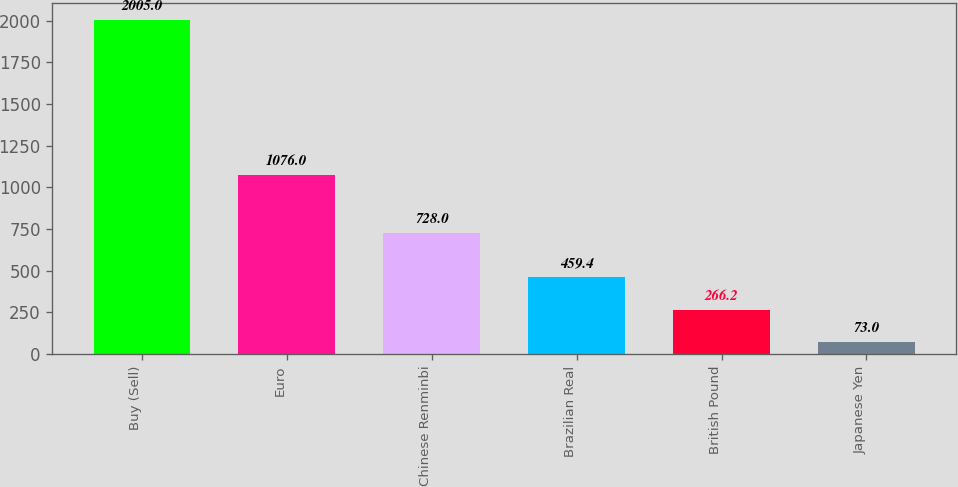Convert chart. <chart><loc_0><loc_0><loc_500><loc_500><bar_chart><fcel>Buy (Sell)<fcel>Euro<fcel>Chinese Renminbi<fcel>Brazilian Real<fcel>British Pound<fcel>Japanese Yen<nl><fcel>2005<fcel>1076<fcel>728<fcel>459.4<fcel>266.2<fcel>73<nl></chart> 